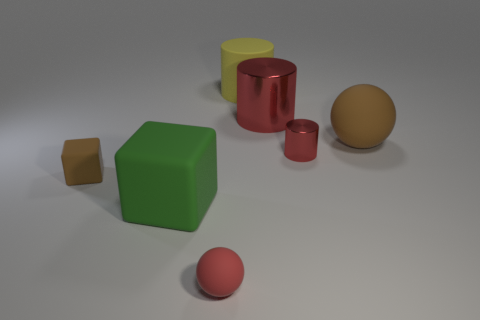Subtract all red metal cylinders. How many cylinders are left? 1 Add 2 big rubber cylinders. How many objects exist? 9 Subtract all blocks. How many objects are left? 5 Subtract 0 purple cubes. How many objects are left? 7 Subtract all green rubber things. Subtract all big brown matte balls. How many objects are left? 5 Add 2 brown rubber spheres. How many brown rubber spheres are left? 3 Add 5 large brown rubber spheres. How many large brown rubber spheres exist? 6 